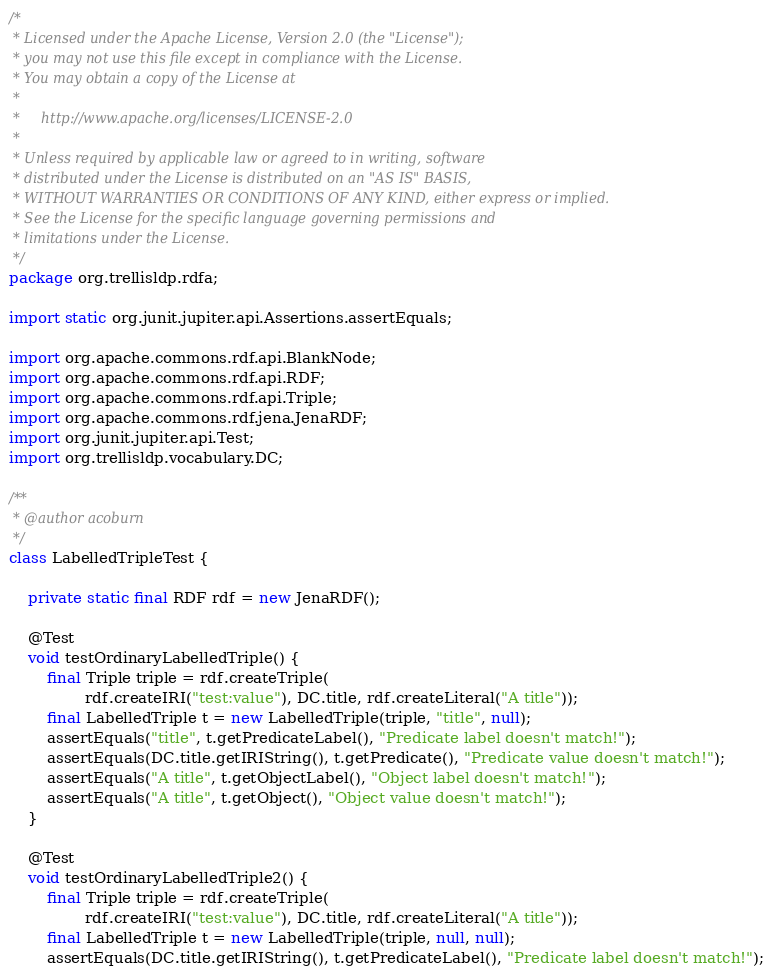<code> <loc_0><loc_0><loc_500><loc_500><_Java_>/*
 * Licensed under the Apache License, Version 2.0 (the "License");
 * you may not use this file except in compliance with the License.
 * You may obtain a copy of the License at
 *
 *     http://www.apache.org/licenses/LICENSE-2.0
 *
 * Unless required by applicable law or agreed to in writing, software
 * distributed under the License is distributed on an "AS IS" BASIS,
 * WITHOUT WARRANTIES OR CONDITIONS OF ANY KIND, either express or implied.
 * See the License for the specific language governing permissions and
 * limitations under the License.
 */
package org.trellisldp.rdfa;

import static org.junit.jupiter.api.Assertions.assertEquals;

import org.apache.commons.rdf.api.BlankNode;
import org.apache.commons.rdf.api.RDF;
import org.apache.commons.rdf.api.Triple;
import org.apache.commons.rdf.jena.JenaRDF;
import org.junit.jupiter.api.Test;
import org.trellisldp.vocabulary.DC;

/**
 * @author acoburn
 */
class LabelledTripleTest {

    private static final RDF rdf = new JenaRDF();

    @Test
    void testOrdinaryLabelledTriple() {
        final Triple triple = rdf.createTriple(
                rdf.createIRI("test:value"), DC.title, rdf.createLiteral("A title"));
        final LabelledTriple t = new LabelledTriple(triple, "title", null);
        assertEquals("title", t.getPredicateLabel(), "Predicate label doesn't match!");
        assertEquals(DC.title.getIRIString(), t.getPredicate(), "Predicate value doesn't match!");
        assertEquals("A title", t.getObjectLabel(), "Object label doesn't match!");
        assertEquals("A title", t.getObject(), "Object value doesn't match!");
    }

    @Test
    void testOrdinaryLabelledTriple2() {
        final Triple triple = rdf.createTriple(
                rdf.createIRI("test:value"), DC.title, rdf.createLiteral("A title"));
        final LabelledTriple t = new LabelledTriple(triple, null, null);
        assertEquals(DC.title.getIRIString(), t.getPredicateLabel(), "Predicate label doesn't match!");</code> 